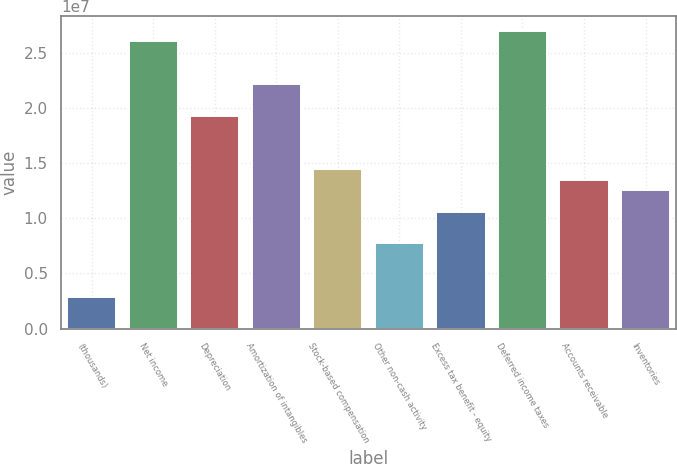<chart> <loc_0><loc_0><loc_500><loc_500><bar_chart><fcel>(thousands)<fcel>Net income<fcel>Depreciation<fcel>Amortization of intangibles<fcel>Stock-based compensation<fcel>Other non-cash activity<fcel>Excess tax benefit - equity<fcel>Deferred income taxes<fcel>Accounts receivable<fcel>Inventories<nl><fcel>2.89014e+06<fcel>2.6007e+07<fcel>1.92646e+07<fcel>2.21542e+07<fcel>1.44486e+07<fcel>7.70616e+06<fcel>1.05958e+07<fcel>2.69702e+07<fcel>1.34854e+07<fcel>1.25222e+07<nl></chart> 